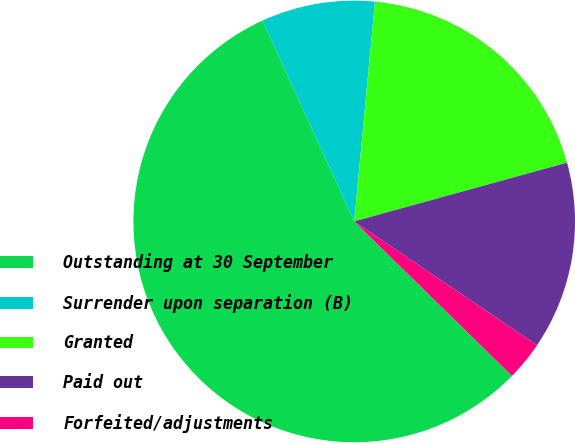<chart> <loc_0><loc_0><loc_500><loc_500><pie_chart><fcel>Outstanding at 30 September<fcel>Surrender upon separation (B)<fcel>Granted<fcel>Paid out<fcel>Forfeited/adjustments<nl><fcel>55.85%<fcel>8.31%<fcel>19.21%<fcel>13.76%<fcel>2.86%<nl></chart> 